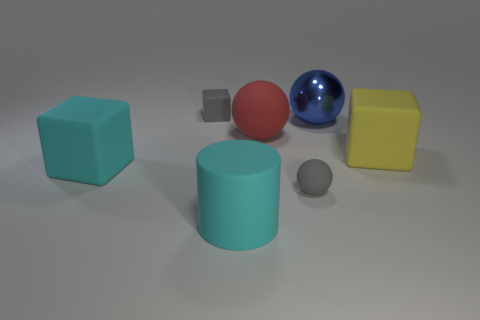Are there fewer yellow rubber blocks on the left side of the cyan matte cylinder than big cyan cylinders?
Your answer should be compact. Yes. There is a large cyan matte object that is in front of the big cyan rubber block; does it have the same shape as the large yellow thing?
Ensure brevity in your answer.  No. Is there any other thing of the same color as the rubber cylinder?
Your response must be concise. Yes. There is a red ball that is the same material as the large yellow block; what size is it?
Make the answer very short. Large. There is a tiny gray thing that is behind the big sphere that is to the left of the tiny gray object right of the big red ball; what is it made of?
Your response must be concise. Rubber. Is the number of tiny yellow rubber blocks less than the number of large yellow matte cubes?
Keep it short and to the point. Yes. Is the yellow object made of the same material as the large red object?
Your response must be concise. Yes. The matte thing that is the same color as the small block is what shape?
Your answer should be very brief. Sphere. There is a matte ball on the left side of the tiny rubber sphere; does it have the same color as the shiny ball?
Offer a terse response. No. How many big blue shiny things are in front of the matte object that is on the left side of the gray block?
Give a very brief answer. 0. 